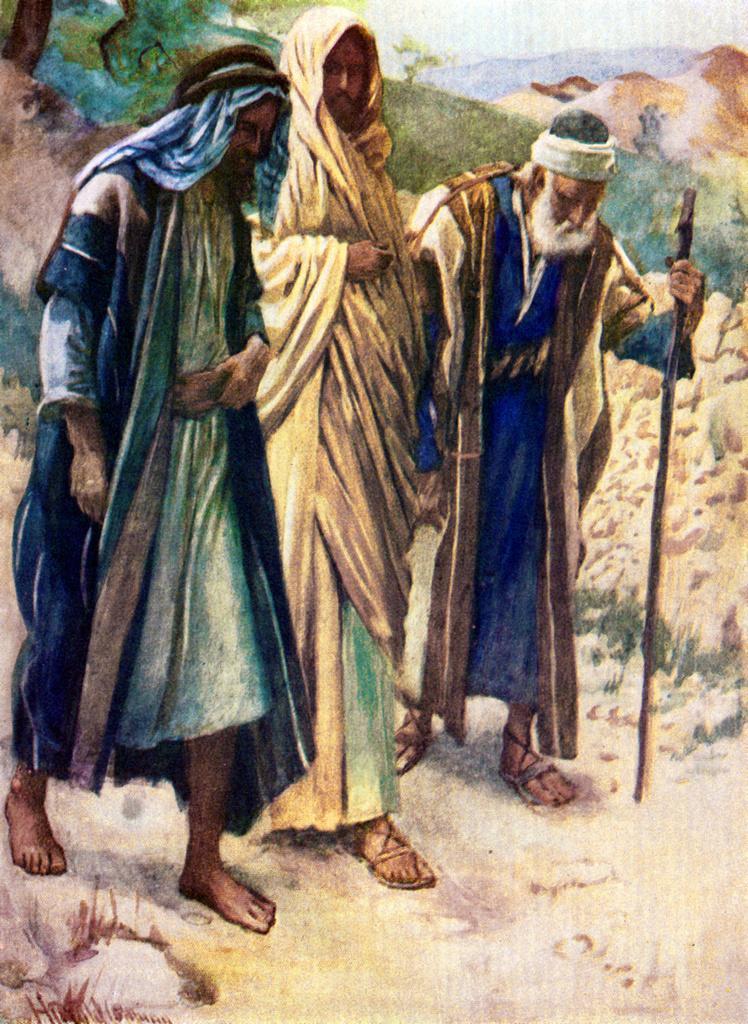Can you describe this image briefly? In this picture we can see the painting of the three men, walking on the ground. Behind we can see some mud and trees. 